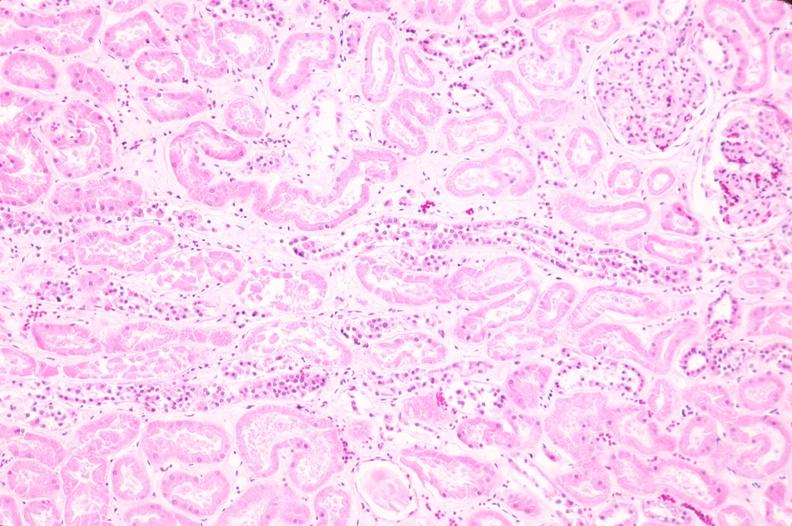where is this?
Answer the question using a single word or phrase. Urinary 